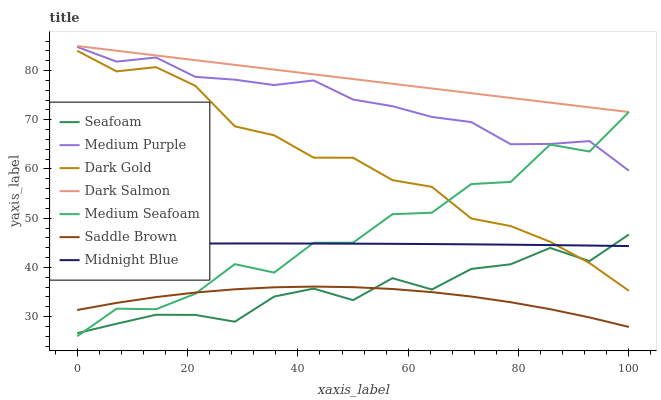Does Midnight Blue have the minimum area under the curve?
Answer yes or no. No. Does Midnight Blue have the maximum area under the curve?
Answer yes or no. No. Is Midnight Blue the smoothest?
Answer yes or no. No. Is Midnight Blue the roughest?
Answer yes or no. No. Does Midnight Blue have the lowest value?
Answer yes or no. No. Does Midnight Blue have the highest value?
Answer yes or no. No. Is Saddle Brown less than Medium Purple?
Answer yes or no. Yes. Is Medium Purple greater than Seafoam?
Answer yes or no. Yes. Does Saddle Brown intersect Medium Purple?
Answer yes or no. No. 